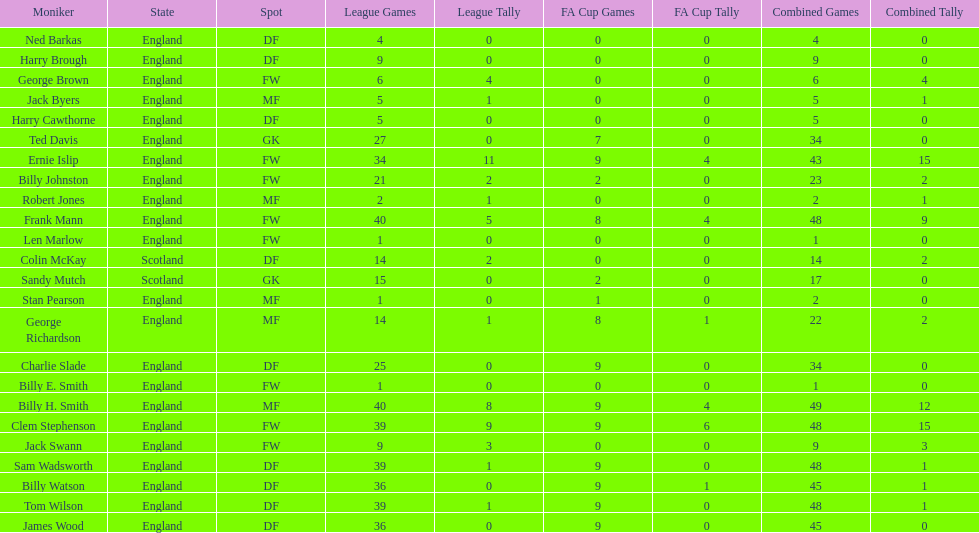Which position is listed the least amount of times on this chart? GK. 